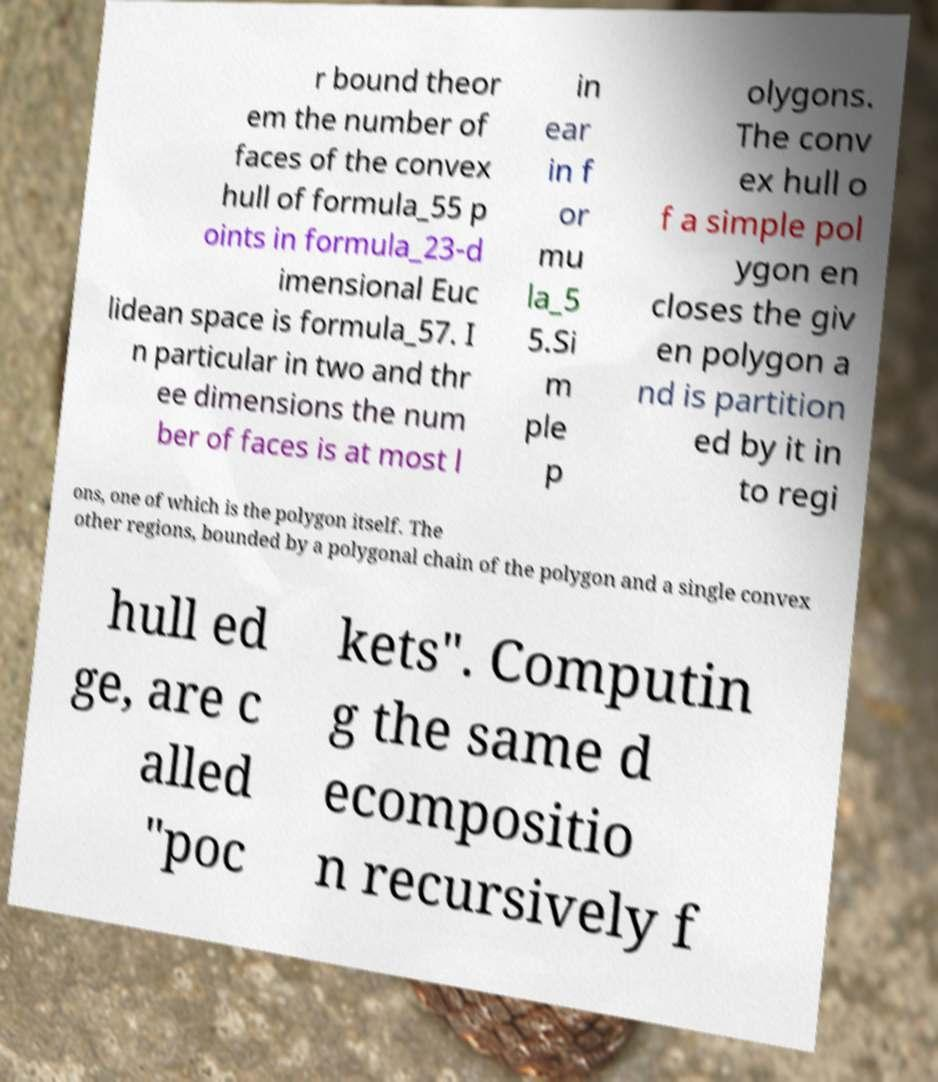I need the written content from this picture converted into text. Can you do that? r bound theor em the number of faces of the convex hull of formula_55 p oints in formula_23-d imensional Euc lidean space is formula_57. I n particular in two and thr ee dimensions the num ber of faces is at most l in ear in f or mu la_5 5.Si m ple p olygons. The conv ex hull o f a simple pol ygon en closes the giv en polygon a nd is partition ed by it in to regi ons, one of which is the polygon itself. The other regions, bounded by a polygonal chain of the polygon and a single convex hull ed ge, are c alled "poc kets". Computin g the same d ecompositio n recursively f 